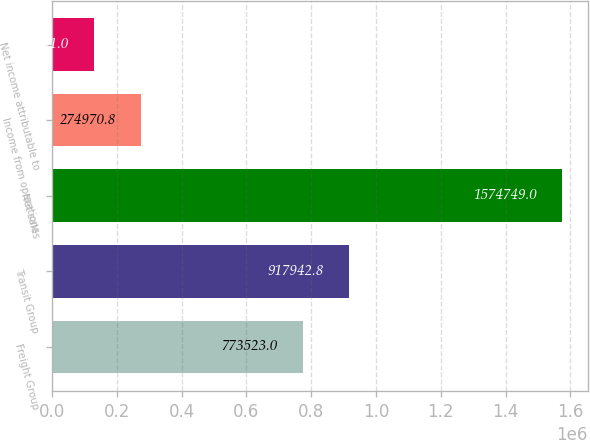Convert chart. <chart><loc_0><loc_0><loc_500><loc_500><bar_chart><fcel>Freight Group<fcel>Transit Group<fcel>Net sales<fcel>Income from operations<fcel>Net income attributable to<nl><fcel>773523<fcel>917943<fcel>1.57475e+06<fcel>274971<fcel>130551<nl></chart> 